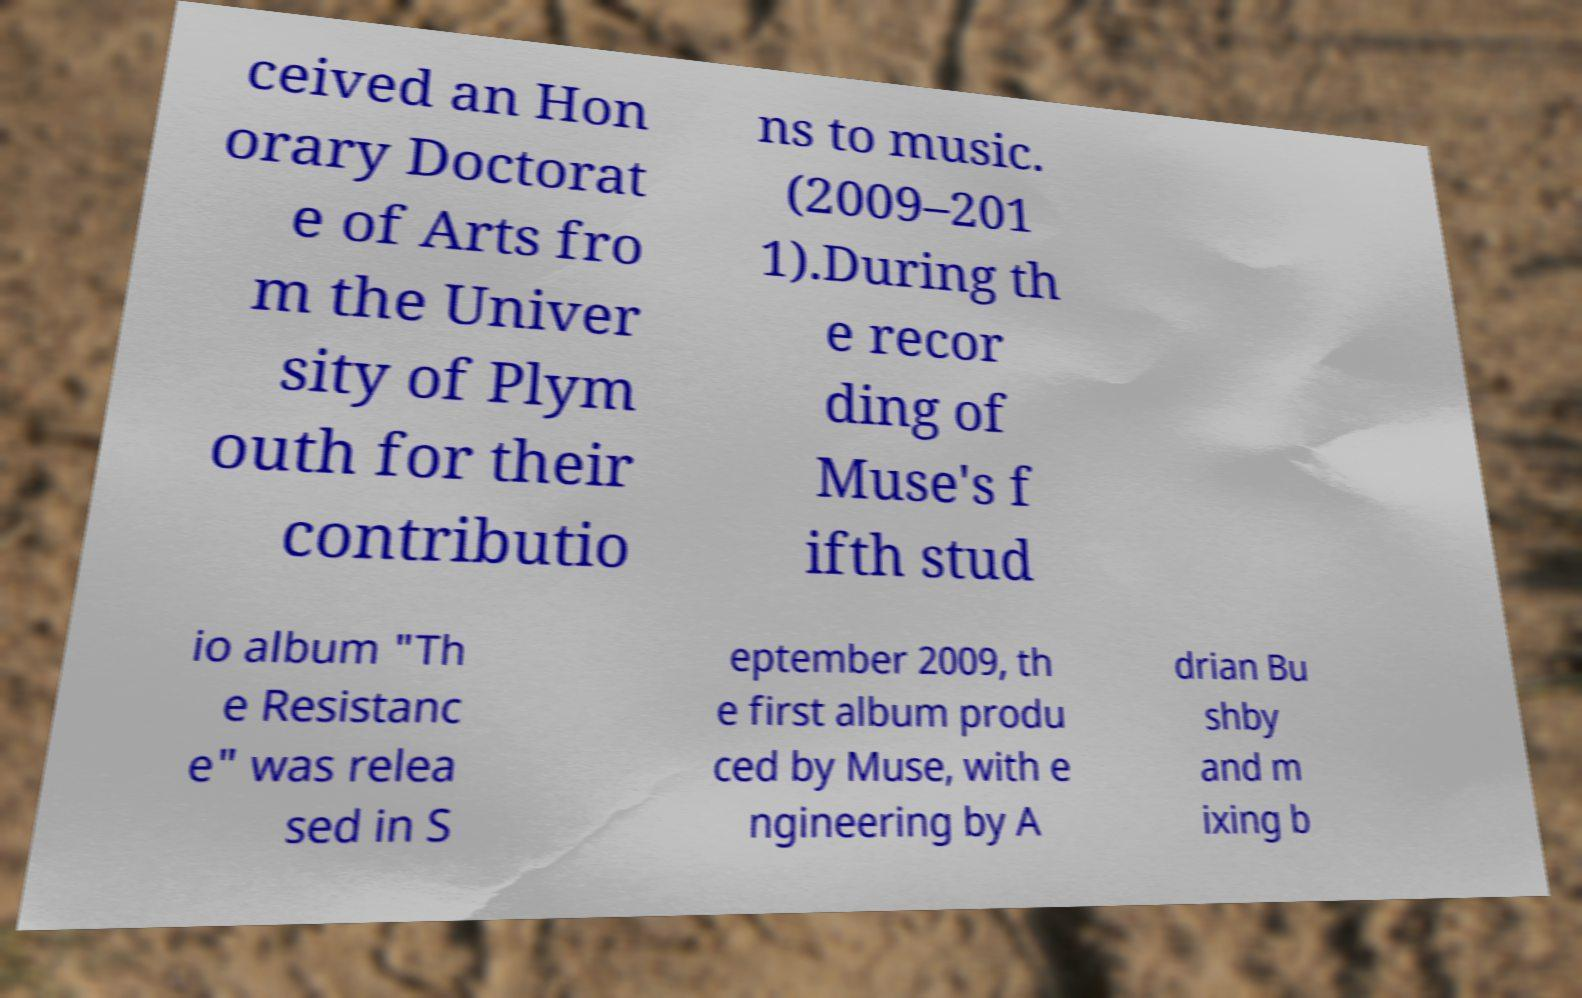There's text embedded in this image that I need extracted. Can you transcribe it verbatim? ceived an Hon orary Doctorat e of Arts fro m the Univer sity of Plym outh for their contributio ns to music. (2009–201 1).During th e recor ding of Muse's f ifth stud io album "Th e Resistanc e" was relea sed in S eptember 2009, th e first album produ ced by Muse, with e ngineering by A drian Bu shby and m ixing b 